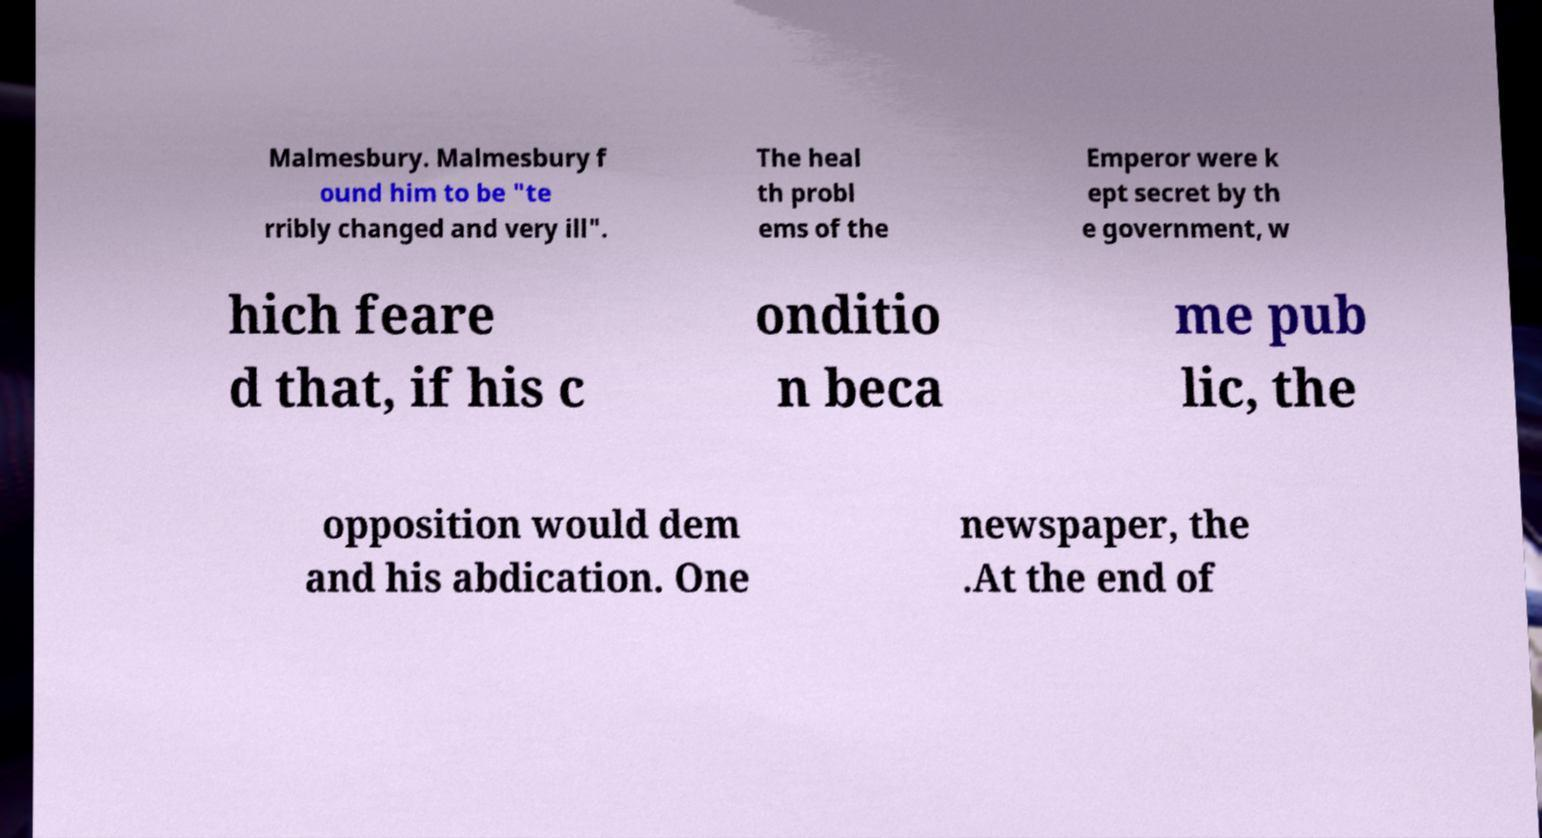Could you assist in decoding the text presented in this image and type it out clearly? Malmesbury. Malmesbury f ound him to be "te rribly changed and very ill". The heal th probl ems of the Emperor were k ept secret by th e government, w hich feare d that, if his c onditio n beca me pub lic, the opposition would dem and his abdication. One newspaper, the .At the end of 